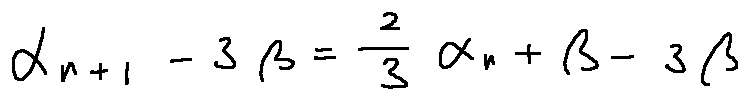<formula> <loc_0><loc_0><loc_500><loc_500>\alpha _ { n + 1 } - 3 \beta = \frac { 2 } { 3 } \alpha _ { n } + \beta - 3 \beta</formula> 